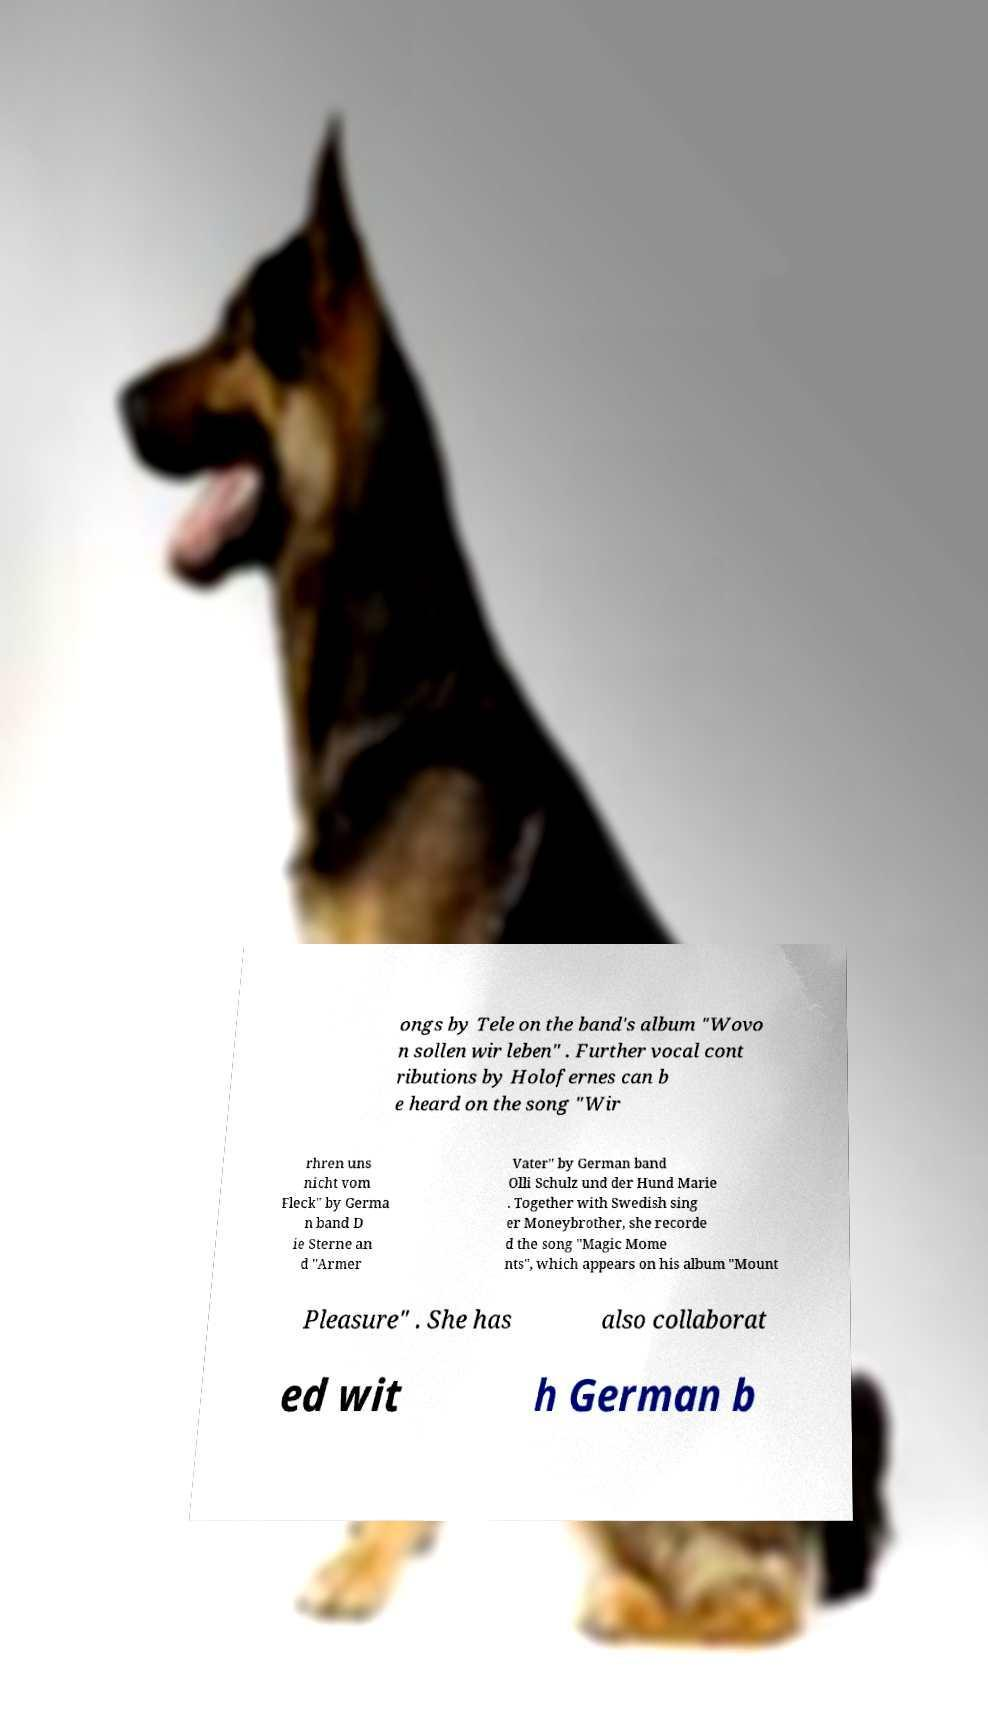Could you assist in decoding the text presented in this image and type it out clearly? ongs by Tele on the band's album "Wovo n sollen wir leben" . Further vocal cont ributions by Holofernes can b e heard on the song "Wir rhren uns nicht vom Fleck" by Germa n band D ie Sterne an d "Armer Vater" by German band Olli Schulz und der Hund Marie . Together with Swedish sing er Moneybrother, she recorde d the song "Magic Mome nts", which appears on his album "Mount Pleasure" . She has also collaborat ed wit h German b 